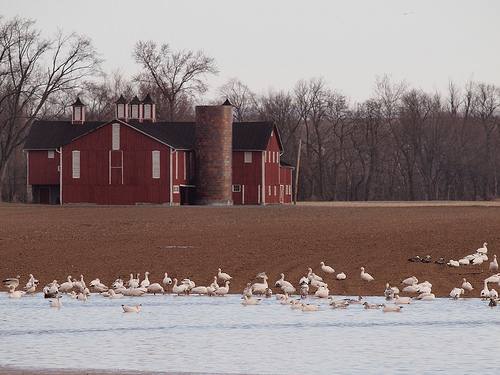<image>
Is there a bird on the lake? No. The bird is not positioned on the lake. They may be near each other, but the bird is not supported by or resting on top of the lake. 